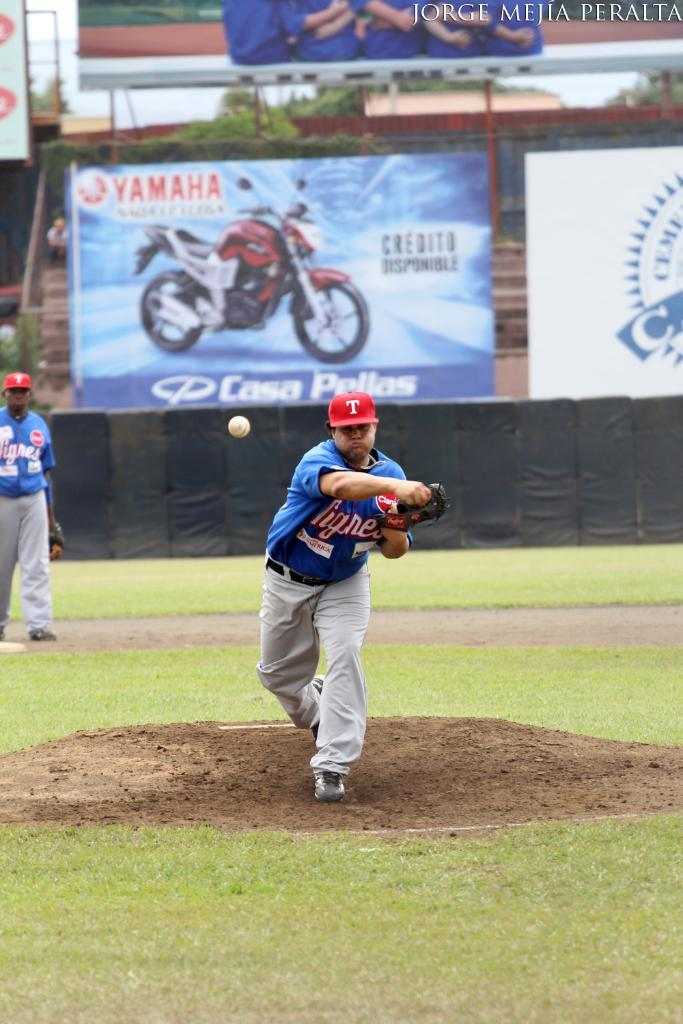Provide a one-sentence caption for the provided image. A Yamaha billboard is visible as a pitcher throws a baseball. 